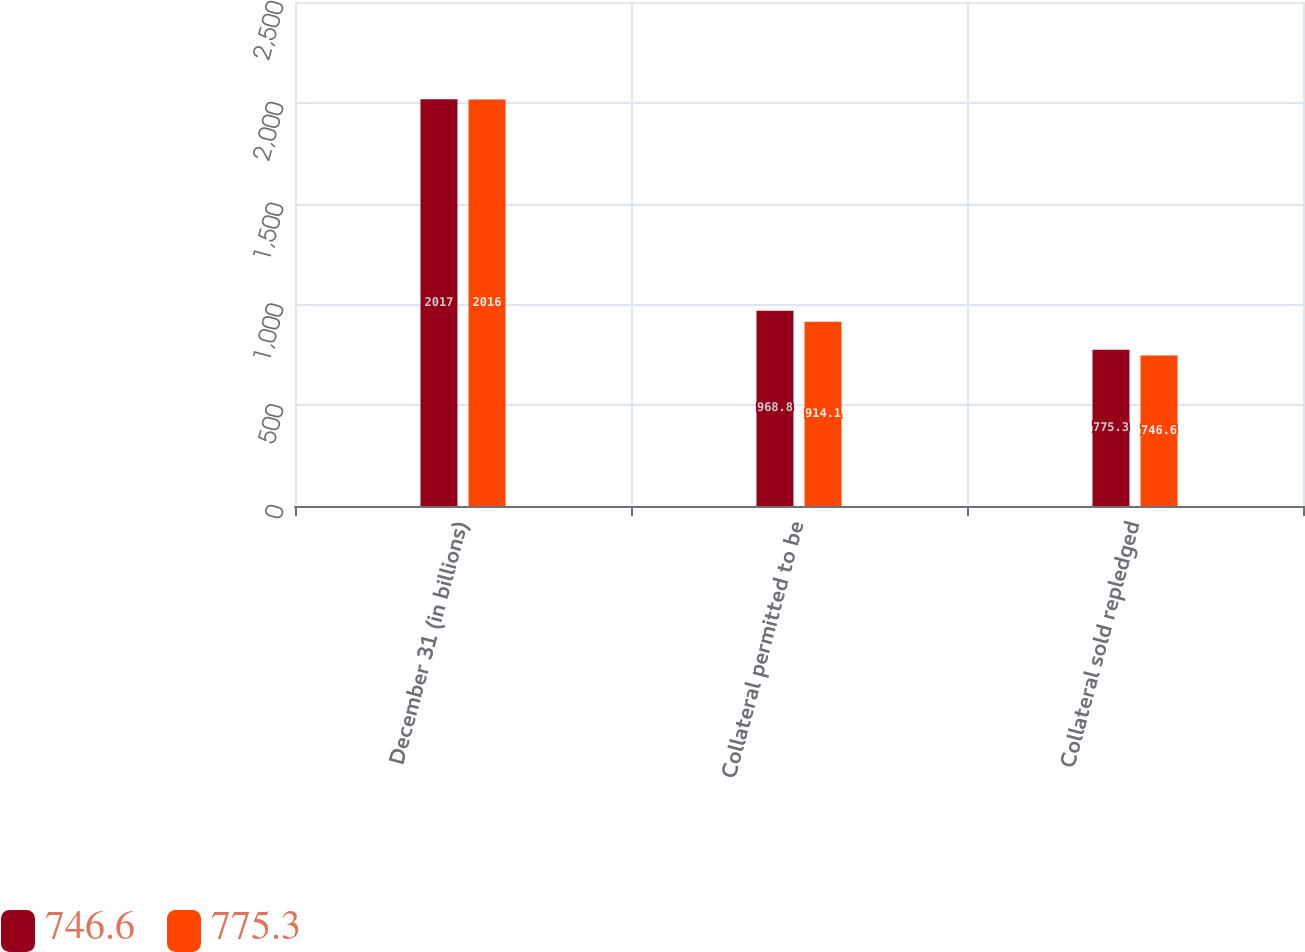<chart> <loc_0><loc_0><loc_500><loc_500><stacked_bar_chart><ecel><fcel>December 31 (in billions)<fcel>Collateral permitted to be<fcel>Collateral sold repledged<nl><fcel>746.6<fcel>2017<fcel>968.8<fcel>775.3<nl><fcel>775.3<fcel>2016<fcel>914.1<fcel>746.6<nl></chart> 